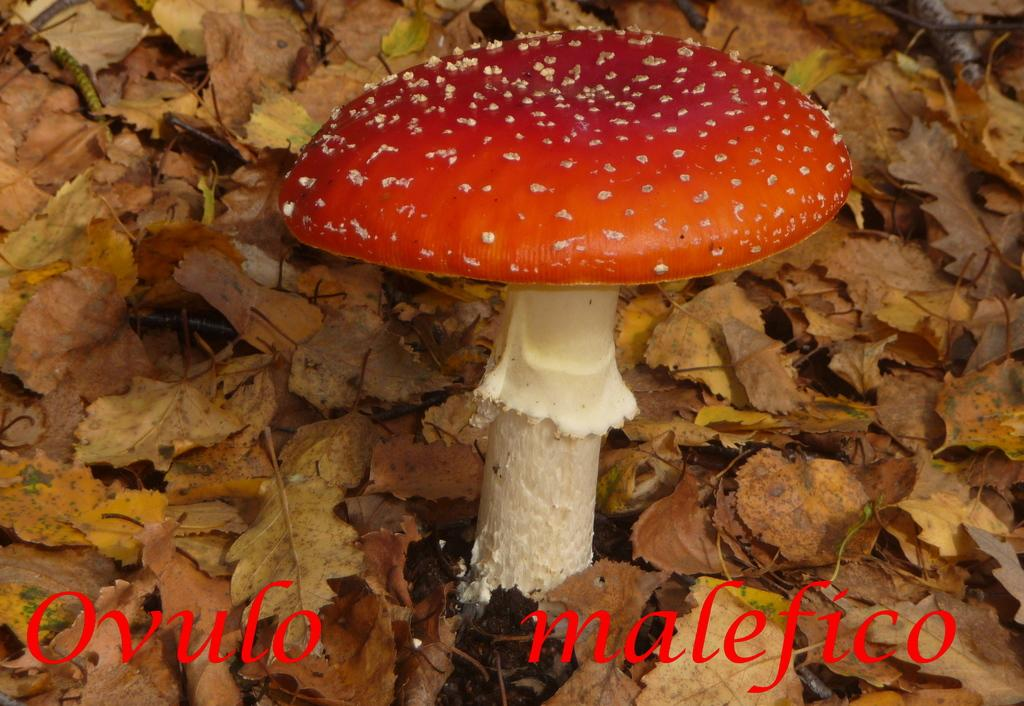What is the main subject of the image? The main subject of the image is a mushroom. Can you describe the colors of the mushroom? The mushroom has white and red colors. Where is the mushroom located in the image? The mushroom is on the ground. What else can be seen in the image besides the mushroom? There are many dried leaves visible in the image. What type of brass instrument is being played in the image? There is no brass instrument present in the image; it features a mushroom on the ground with dried leaves. 